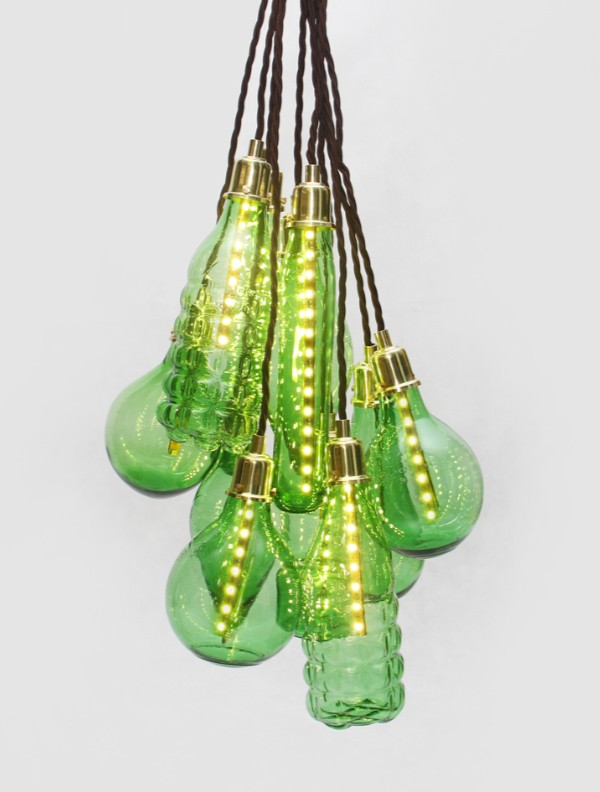Considering the unique design and craftsmanship of these light fixtures, what might be the inspiration behind their shapes, and how do they contribute to the overall aesthetic of the lighting design? The inspiration behind the shapes of these light fixtures could potentially be drawn from natural and organic forms, such as various fruits, flora, and even water droplets. The handcrafted nature of each fixture showcases a unique artistic expression, contributing to an eclectic and bespoke aesthetic. This thoughtful design allows for a playful interaction of light and shadow that heightens visual interest and can adapt to various interior styles, from modern minimalist to bohemian chic. The integrated warm LED lights emphasize the individual contours and textures of the glass, making each piece a focal point while accentuating the craftsmanship and creative vision of the design. This collection not only illuminates spaces but also adds an artistic and sophisticated flair to the environment. 